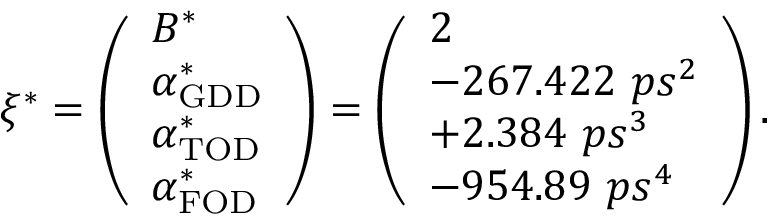Convert formula to latex. <formula><loc_0><loc_0><loc_500><loc_500>\xi ^ { * } = \left ( \begin{array} { l } { B ^ { * } } \\ { \alpha _ { G D D } ^ { * } } \\ { \alpha _ { T O D } ^ { * } } \\ { \alpha _ { F O D } ^ { * } } \end{array} \right ) = \left ( \begin{array} { l } { 2 } \\ { - 2 6 7 . 4 2 2 \ p s ^ { 2 } } \\ { + 2 . 3 8 4 \ p s ^ { 3 } } \\ { - 9 5 4 . 8 9 \ p s ^ { 4 } } \end{array} \right ) .</formula> 